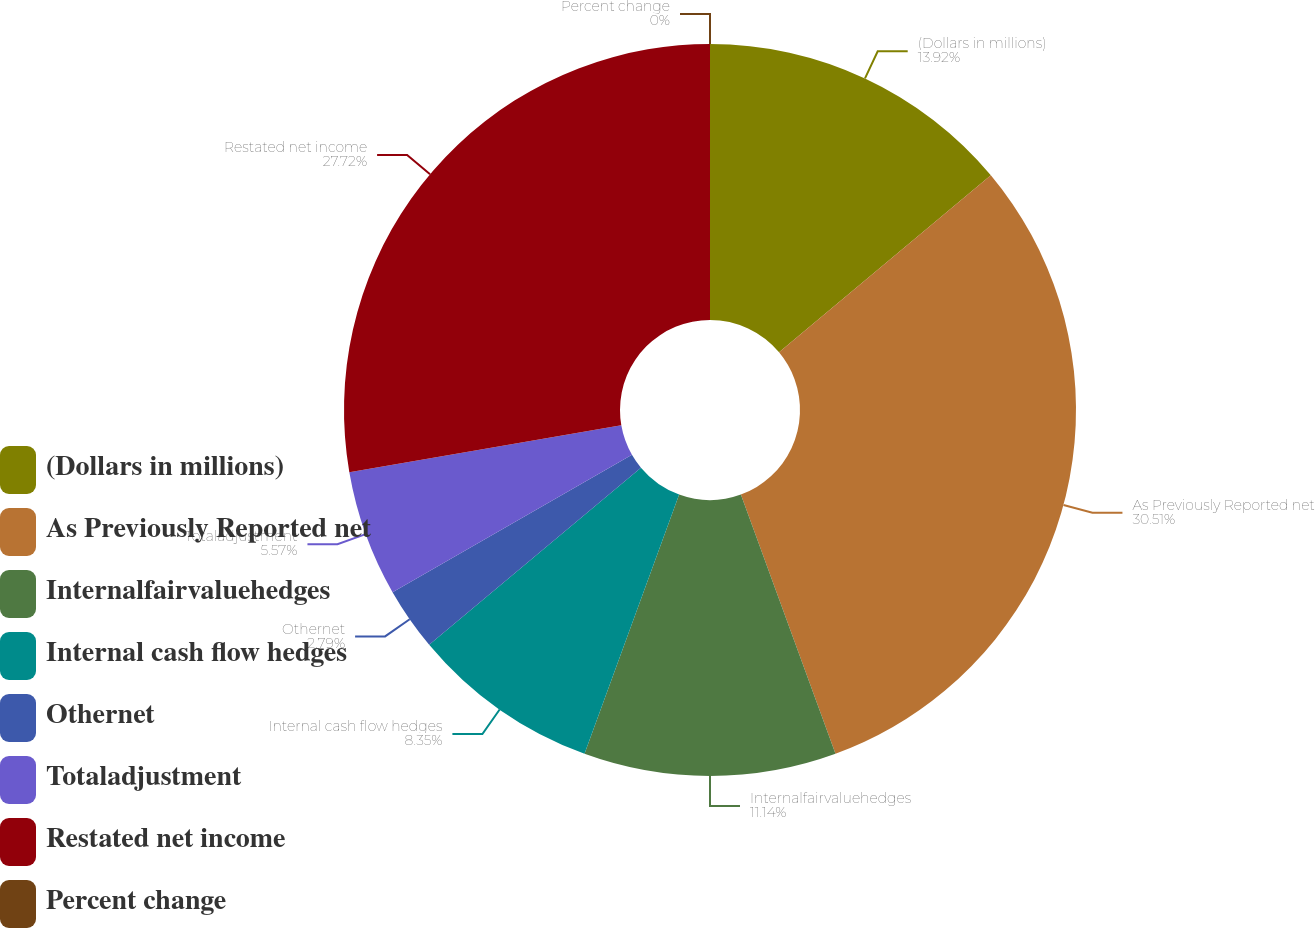Convert chart. <chart><loc_0><loc_0><loc_500><loc_500><pie_chart><fcel>(Dollars in millions)<fcel>As Previously Reported net<fcel>Internalfairvaluehedges<fcel>Internal cash flow hedges<fcel>Othernet<fcel>Totaladjustment<fcel>Restated net income<fcel>Percent change<nl><fcel>13.92%<fcel>30.51%<fcel>11.14%<fcel>8.35%<fcel>2.79%<fcel>5.57%<fcel>27.72%<fcel>0.0%<nl></chart> 